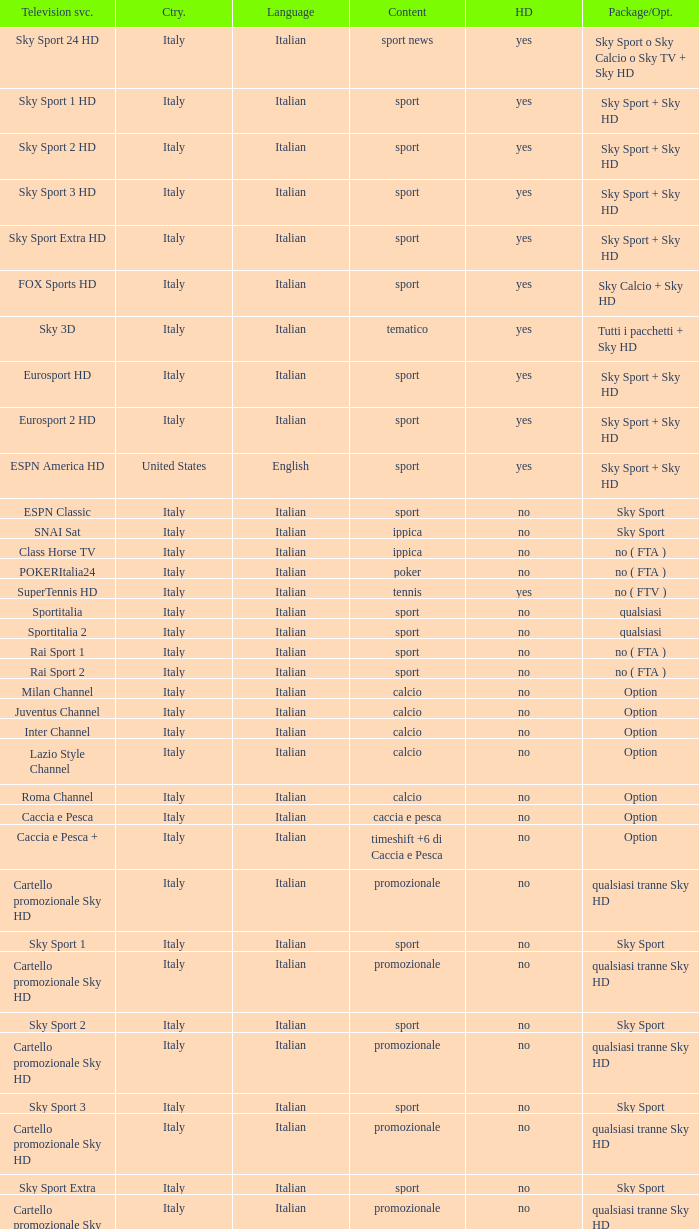What is Language, when Content is Sport, when HDTV is No, and when Television Service is ESPN America? Italian. 